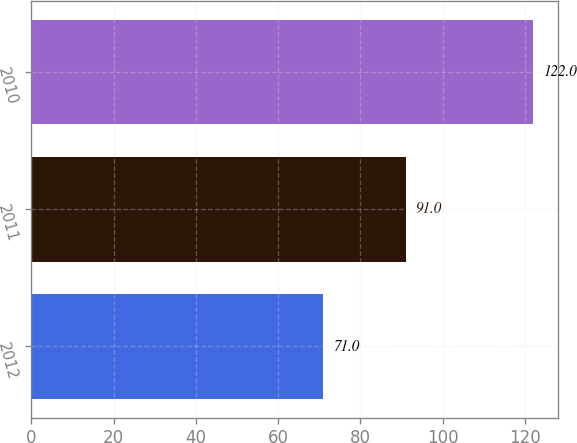Convert chart. <chart><loc_0><loc_0><loc_500><loc_500><bar_chart><fcel>2012<fcel>2011<fcel>2010<nl><fcel>71<fcel>91<fcel>122<nl></chart> 